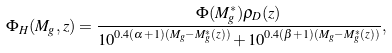<formula> <loc_0><loc_0><loc_500><loc_500>\Phi _ { H } ( M _ { g } , z ) = \frac { \Phi ( M _ { g } ^ { \ast } ) \rho _ { D } ( z ) } { 1 0 ^ { 0 . 4 ( \alpha + 1 ) ( M _ { g } - M _ { g } ^ { \ast } ( z ) ) } + 1 0 ^ { 0 . 4 ( \beta + 1 ) ( M _ { g } - M _ { g } ^ { \ast } ( z ) ) } } ,</formula> 